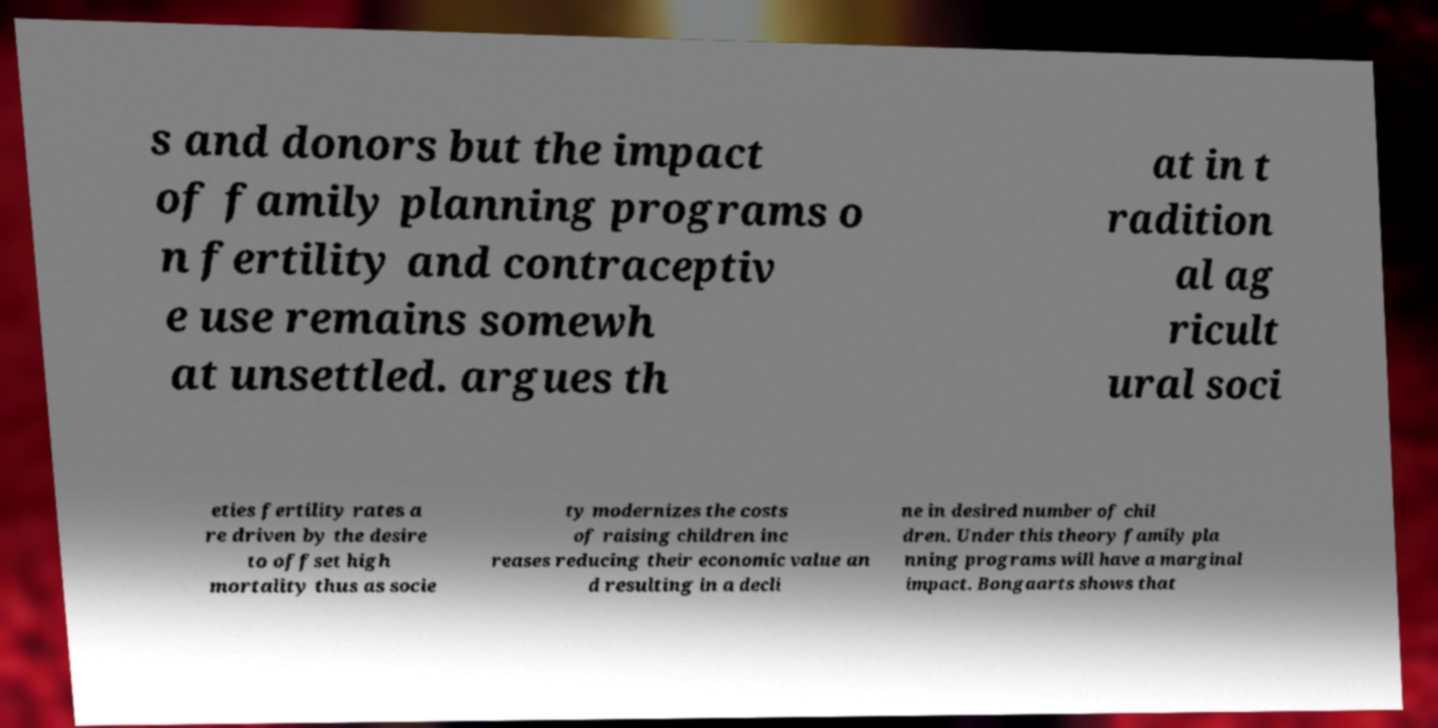I need the written content from this picture converted into text. Can you do that? s and donors but the impact of family planning programs o n fertility and contraceptiv e use remains somewh at unsettled. argues th at in t radition al ag ricult ural soci eties fertility rates a re driven by the desire to offset high mortality thus as socie ty modernizes the costs of raising children inc reases reducing their economic value an d resulting in a decli ne in desired number of chil dren. Under this theory family pla nning programs will have a marginal impact. Bongaarts shows that 